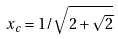<formula> <loc_0><loc_0><loc_500><loc_500>x _ { c } = 1 / \sqrt { 2 + \sqrt { 2 } }</formula> 